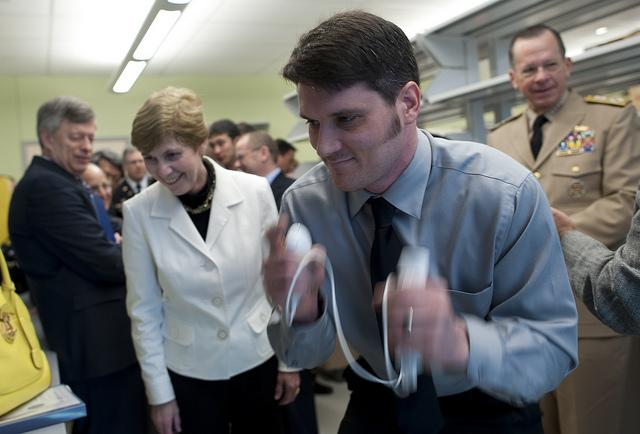What is the hair on the side of the man's cheek called? Please explain your reasoning. sideburn. The man has sideburns on the side of his face. 